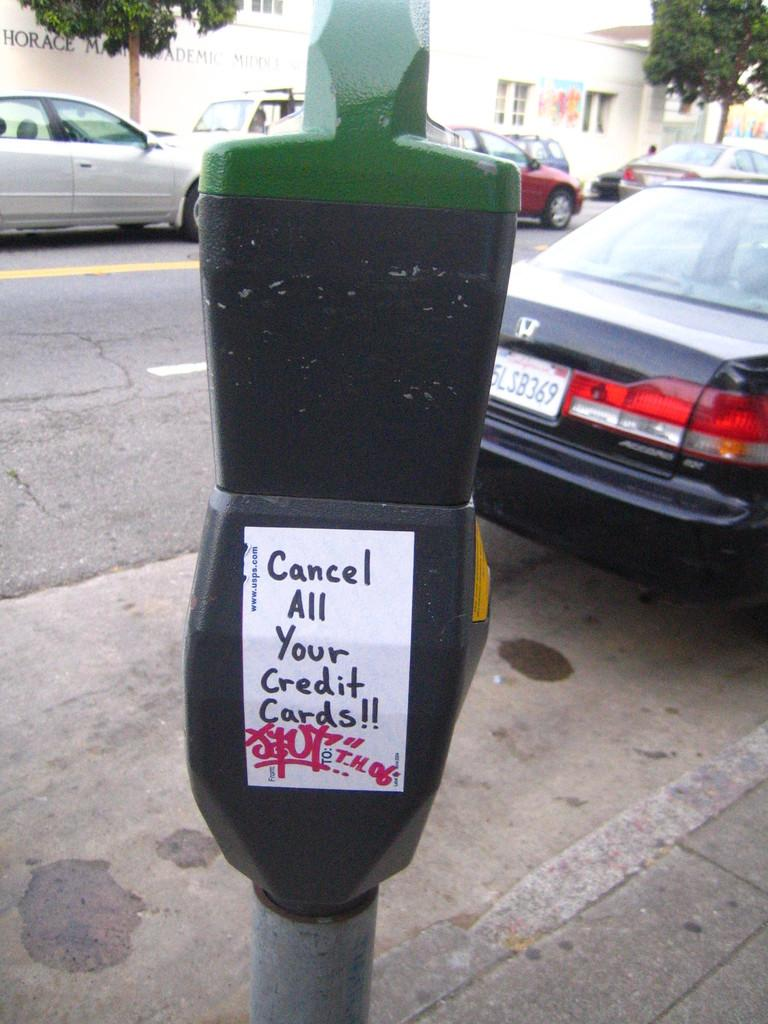<image>
Provide a brief description of the given image. A sticker saying cancel all your credit cards is stuck to a parking meter. 